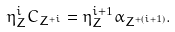<formula> <loc_0><loc_0><loc_500><loc_500>\eta _ { Z } ^ { i } C _ { Z ^ { + i } } = \eta _ { Z } ^ { i + 1 } \alpha _ { Z ^ { + ( i + 1 ) } } .</formula> 